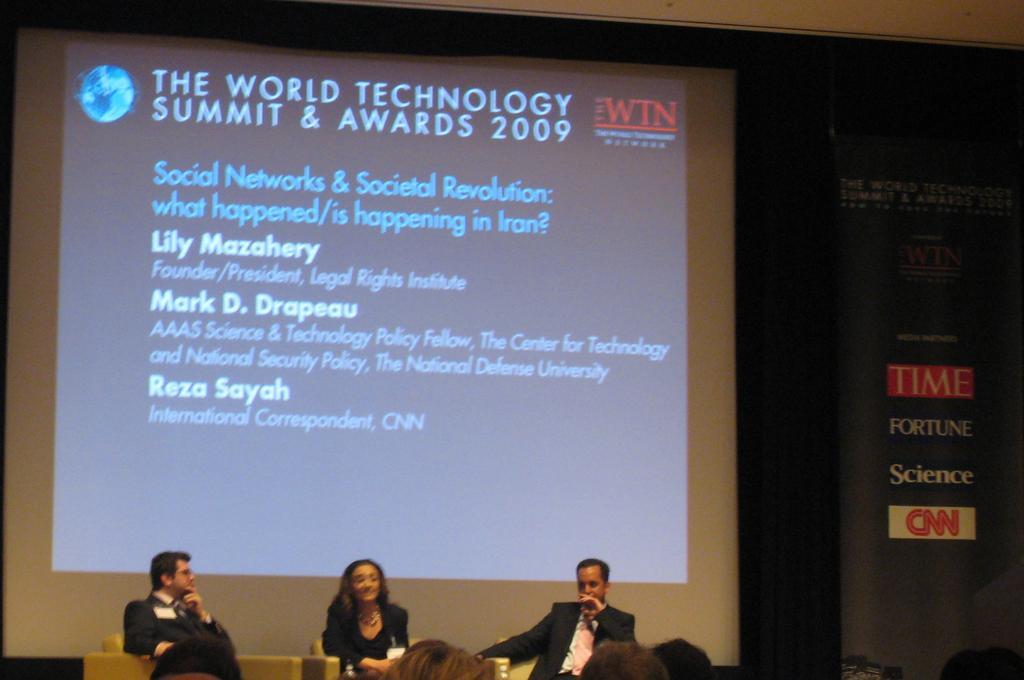Describe this image in one or two sentences. In this image I can see three persons sitting. In front the person is wearing black color dress. Background I can see the projection screen and I can also see the cloth in black color and I can also see something written on the cloth. 